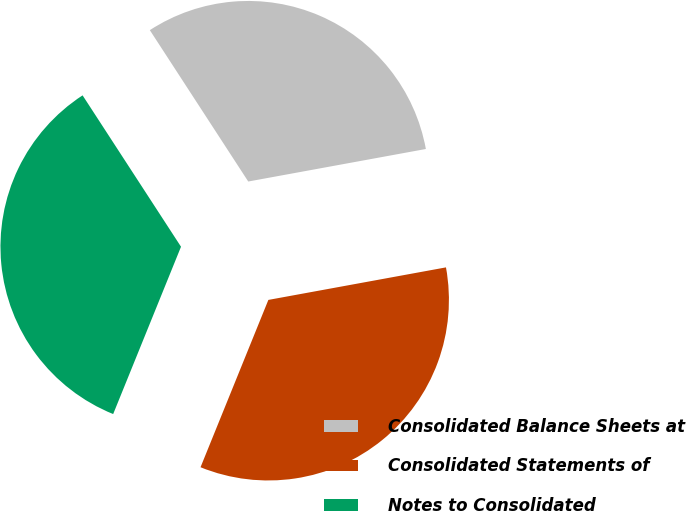Convert chart to OTSL. <chart><loc_0><loc_0><loc_500><loc_500><pie_chart><fcel>Consolidated Balance Sheets at<fcel>Consolidated Statements of<fcel>Notes to Consolidated<nl><fcel>31.29%<fcel>34.01%<fcel>34.69%<nl></chart> 